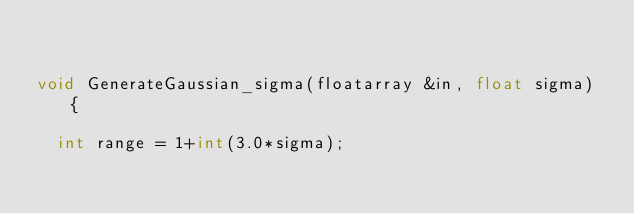Convert code to text. <code><loc_0><loc_0><loc_500><loc_500><_C++_>

void GenerateGaussian_sigma(floatarray &in, float sigma) {
  
  int range = 1+int(3.0*sigma);</code> 